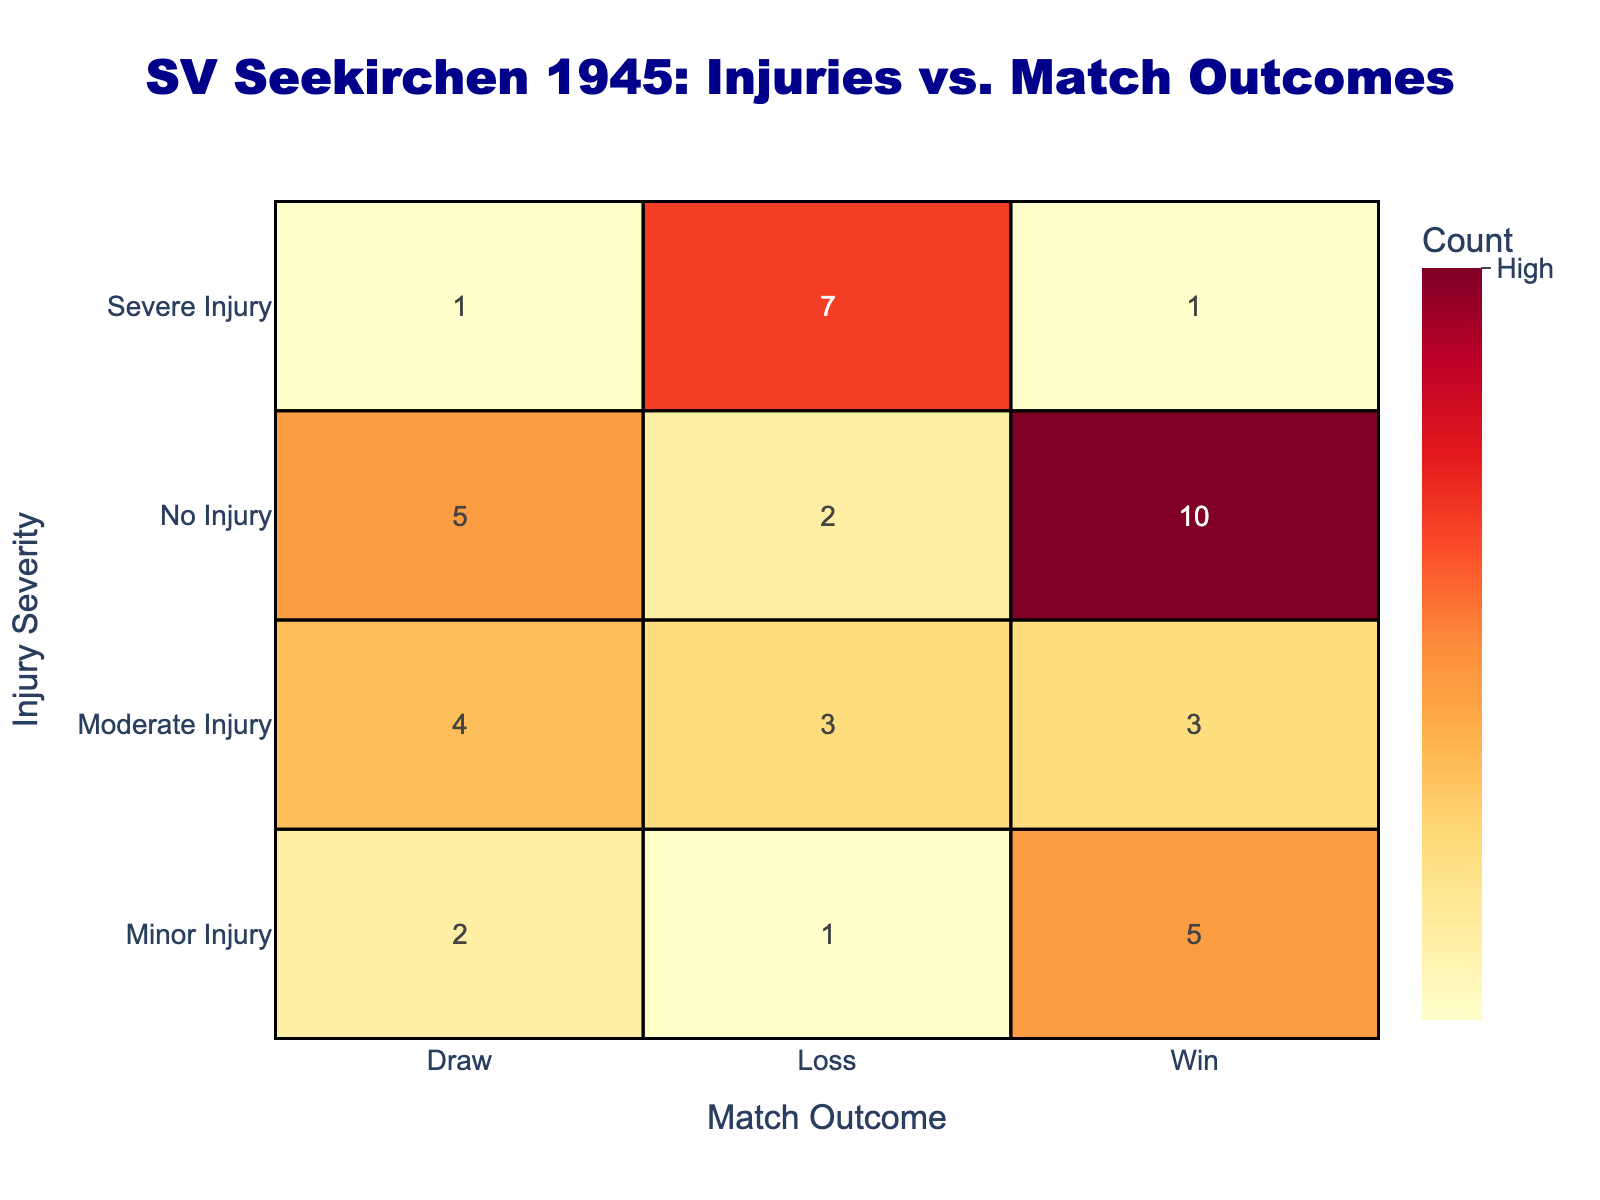What is the count of matches won by players with no injuries? According to the table, the count of matches won by players with no injuries is given directly in the 'No Injury' row and 'Win' column, which shows a count of 10.
Answer: 10 How many total draws were recorded for players with moderate injuries? The total draws for players with moderate injuries can be found in the 'Moderate Injury' row under the 'Draw' column, where the count is 4.
Answer: 4 Is the count of losses for players with severe injuries higher than for those with minor injuries? Looking at the table, the count of losses for players with severe injuries is 7 and for minor injuries is 1. Since 7 is greater than 1, the statement is true.
Answer: Yes What is the total number of wins across all injury types? To calculate the total number of wins, we sum the counts in the 'Win' column: 5 (Minor) + 3 (Moderate) + 1 (Severe) + 10 (No Injury) = 19. Therefore, the total number of wins is 19.
Answer: 19 Given the data, what percentage of matches ended in a draw when players had a minor injury? The count of draws with minor injuries is 2. The total match outcomes for minor injuries is 5 (Win) + 2 (Draw) + 1 (Loss) = 8. To find the percentage, calculate (2/8) * 100 = 25%.
Answer: 25% How many more losses were there for players with severe injuries compared to those with moderate injuries? The count of losses for players with severe injuries is 7, while for moderate injuries it is 3. The difference between these two counts is 7 - 3 = 4.
Answer: 4 Is there any instance of a draw when players had a severe injury? By examining the table, there is 1 count of a draw for severe injuries, indicating that there was indeed an outcome of that nature.
Answer: Yes What is the total number of matches recorded for players with any injuries? To find the total number of matches for players with injuries, sum the counts across all injury severities: (5 + 2 + 1) + (3 + 4 + 3) + (1 + 1 + 7) = 30.
Answer: 30 Which type of injury had the highest number of wins, and how many were recorded? By looking at the wins: 5 for minor injuries, 3 for moderate injuries, 1 for severe injuries, and 10 for no injuries. The highest is the 10 wins from players with no injuries.
Answer: No Injury, 10 